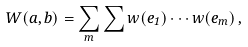Convert formula to latex. <formula><loc_0><loc_0><loc_500><loc_500>W ( a , b ) = \sum _ { m } \sum w ( e _ { 1 } ) \cdots w ( e _ { m } ) \, ,</formula> 